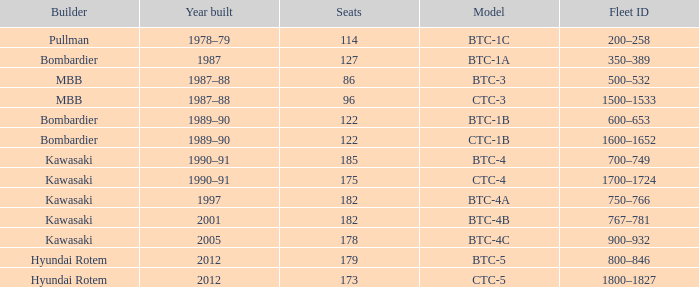For the train built in 2012 with less than 179 seats, what is the Fleet ID? 1800–1827. 